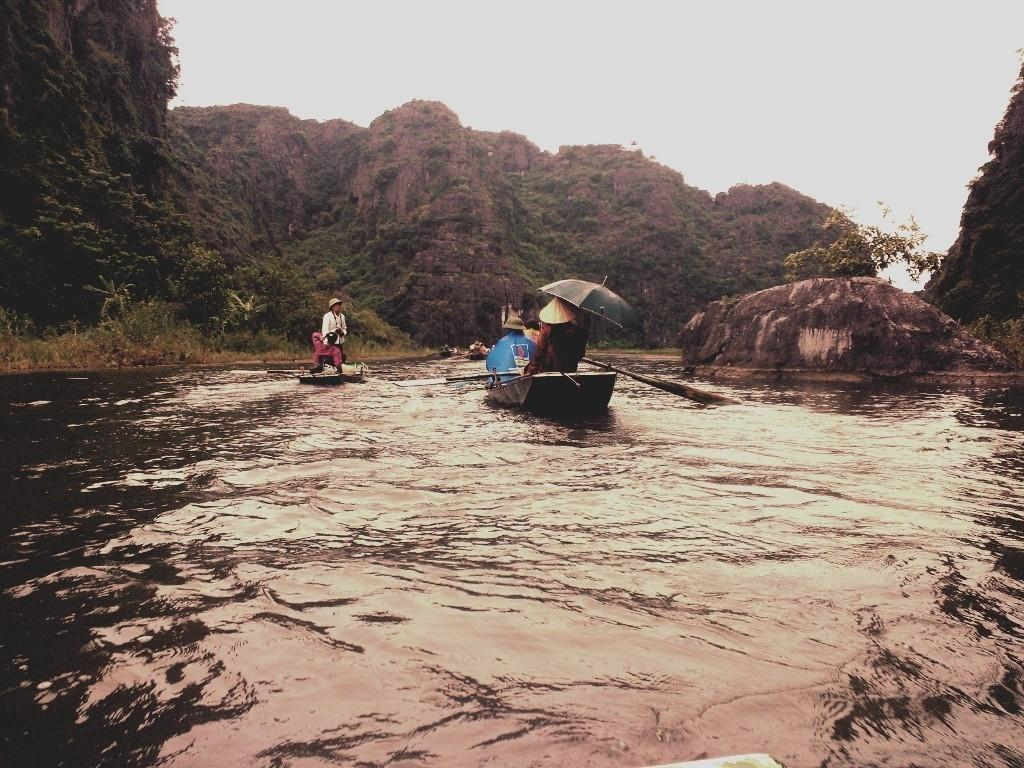What is the main subject of the image? The main subject of the image is persons on a boat. What is the boat doing in the image? The boat is sailing on the water. What can be seen in the background of the image? Hills, trees, and the sky are visible in the background of the image. How many brothers are on the boat in the image? There is no information about brothers in the image; it only shows persons on a boat sailing on the water. Can you see any snails on the boat or in the water in the image? There are no snails visible in the image; it only shows persons on a boat sailing on the water. 